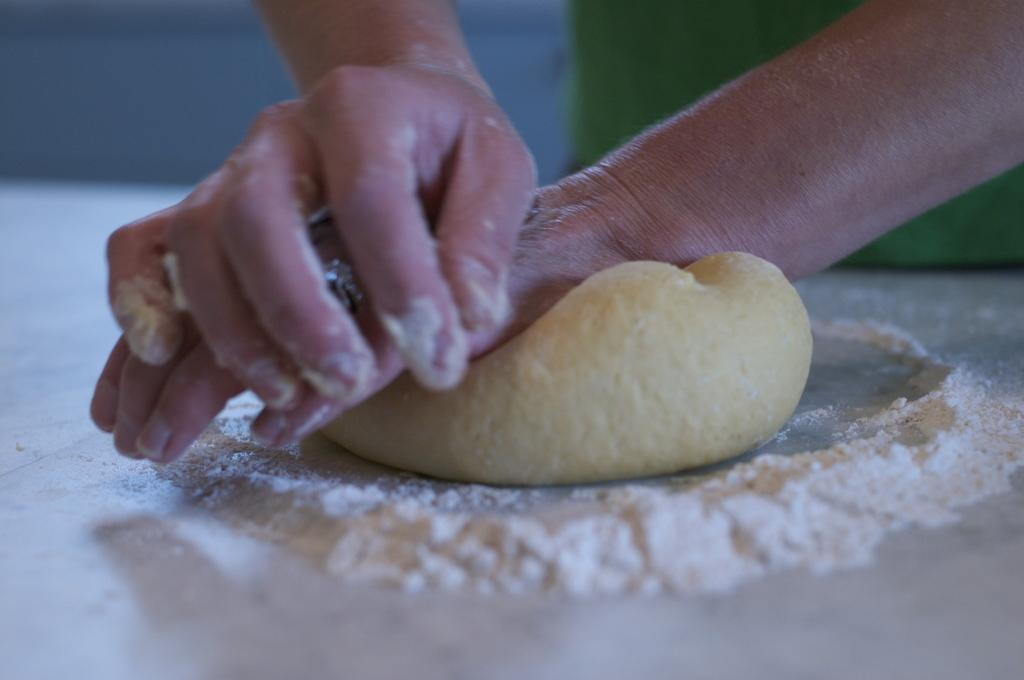What is the person in the image doing? The person is making dough. What can be seen on the table in the image? There is flour on the table in the image. How many socks are visible on the person's feet in the image? There is no information about socks or the person's feet in the image, so we cannot determine the number of socks. 